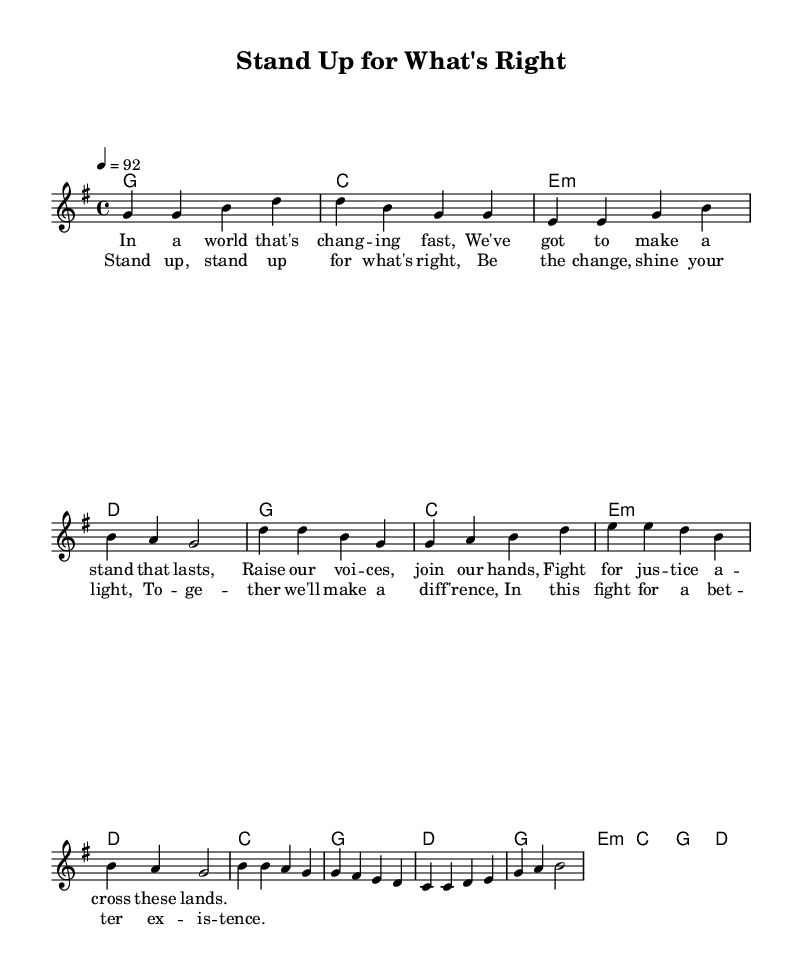What is the key signature of this music? The key signature is G major, which has one sharp (F#). This can be identified by looking at the key signature indicated at the beginning of the score.
Answer: G major What is the time signature of this music? The time signature is 4/4, indicated at the beginning of the sheet music. This means there are four beats in each measure, and the quarter note gets one beat.
Answer: 4/4 What is the tempo marking of this music? The tempo marking is 92, which means the piece should be played at 92 beats per minute. This is provided at the beginning of the score as a tempo indication in the form "4 = 92".
Answer: 92 How many measures are in the first verse? The first verse consists of four measures, which can be counted by looking at the notation under the melody line for the verse section.
Answer: Four Which section of the song features the lyrics "Stand up, stand up for what's right"? The lyrics are found in the chorus section of the song, identifiable by the distinct lyrical phrasing that follows the verse in the score.
Answer: Chorus Identify the chord played during the second measure of the verse. The chord played during the second measure of the verse is C major, which can be noted by the chord indicated above the melody for that specific measure.
Answer: C What message does this song convey regarding social change? The overall message of the song emphasizes the importance of standing up for what is right and being a positive change in the world, which can be inferred from the themes expressed in the lyrics.
Answer: Stand up for what's right 